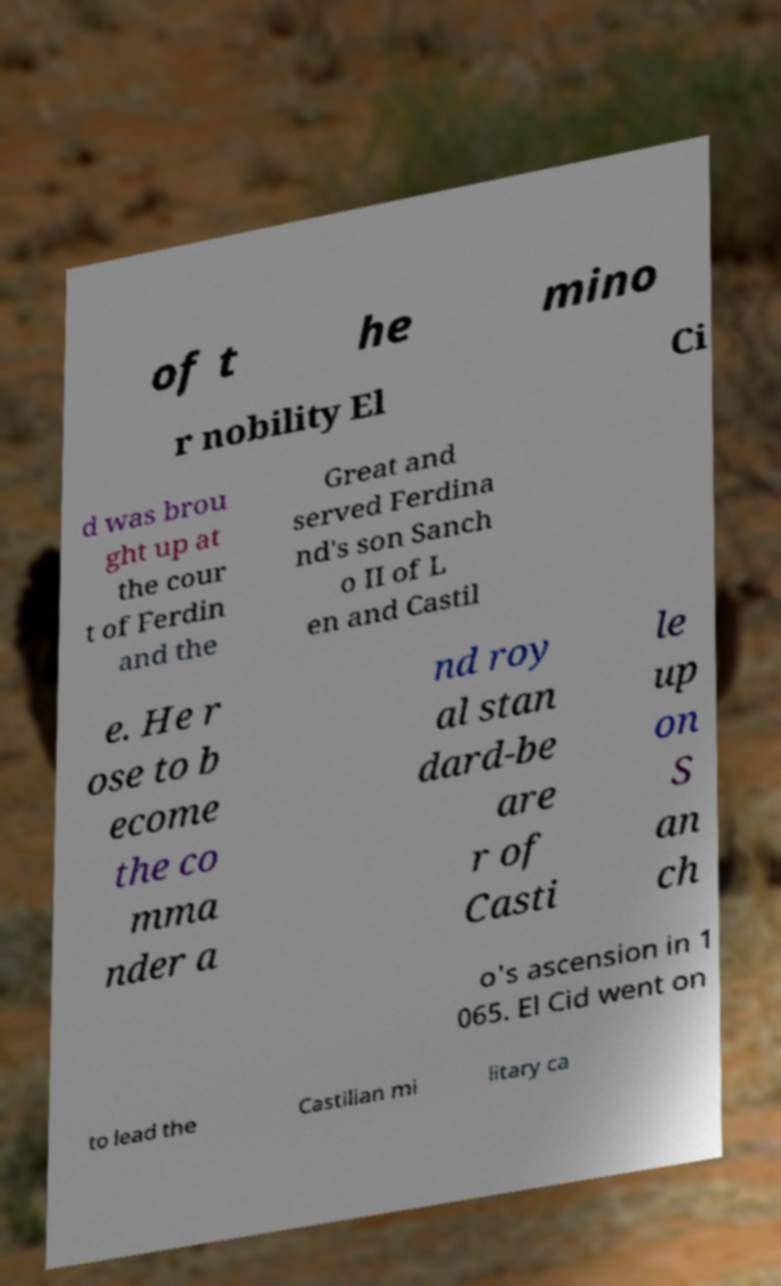Could you assist in decoding the text presented in this image and type it out clearly? of t he mino r nobility El Ci d was brou ght up at the cour t of Ferdin and the Great and served Ferdina nd's son Sanch o II of L en and Castil e. He r ose to b ecome the co mma nder a nd roy al stan dard-be are r of Casti le up on S an ch o's ascension in 1 065. El Cid went on to lead the Castilian mi litary ca 